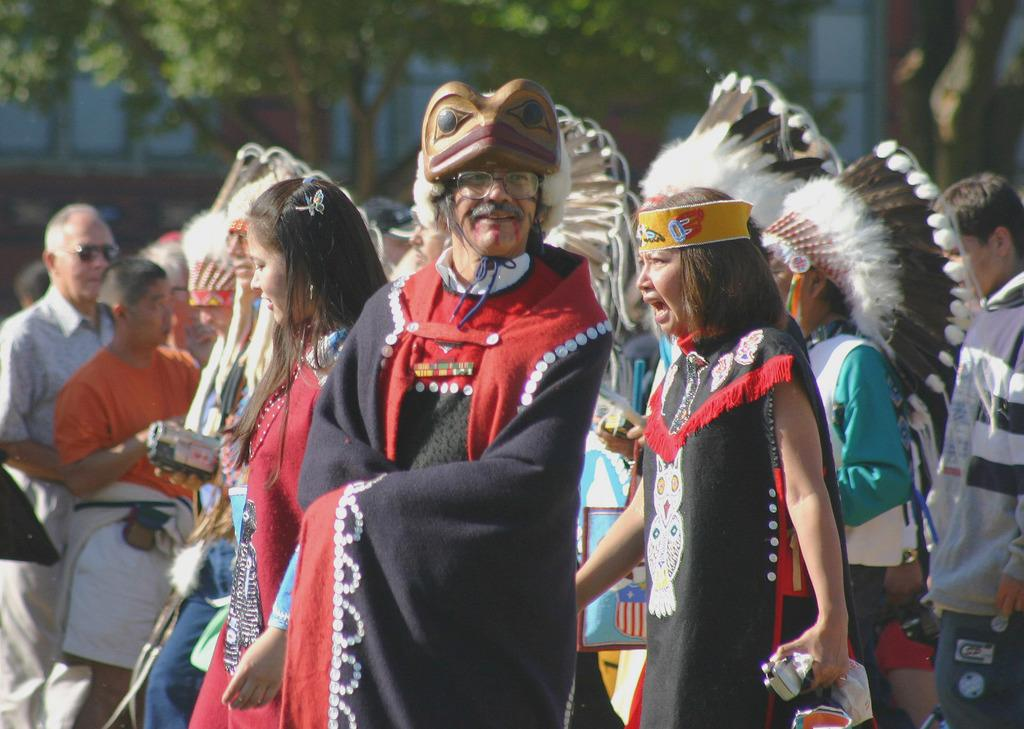What is happening in the middle of the image? There are people standing in the middle of the image. What are the people holding in their hands? The people are holding something in their hands. What can be seen in the background of the image? Trees and buildings are visible at the top of the image. How would you describe the clarity of the background in the image? The background of the image is blurred. Can you tell me how many steel bars are being stretched by the people in the image? There is no mention of steel bars or stretching in the image; the people are simply holding something in their hands. 